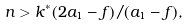Convert formula to latex. <formula><loc_0><loc_0><loc_500><loc_500>n > k ^ { * } ( 2 a _ { 1 } - f ) / ( a _ { 1 } - f ) ,</formula> 